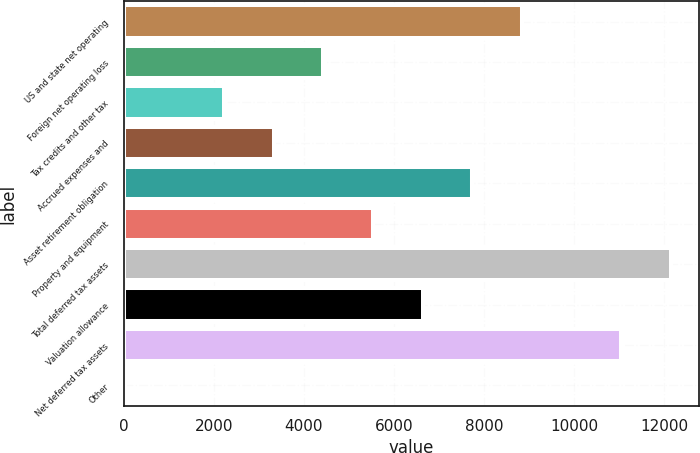Convert chart to OTSL. <chart><loc_0><loc_0><loc_500><loc_500><bar_chart><fcel>US and state net operating<fcel>Foreign net operating loss<fcel>Tax credits and other tax<fcel>Accrued expenses and<fcel>Asset retirement obligation<fcel>Property and equipment<fcel>Total deferred tax assets<fcel>Valuation allowance<fcel>Net deferred tax assets<fcel>Other<nl><fcel>8848.6<fcel>4433.8<fcel>2226.4<fcel>3330.1<fcel>7744.9<fcel>5537.5<fcel>12159.7<fcel>6641.2<fcel>11056<fcel>19<nl></chart> 